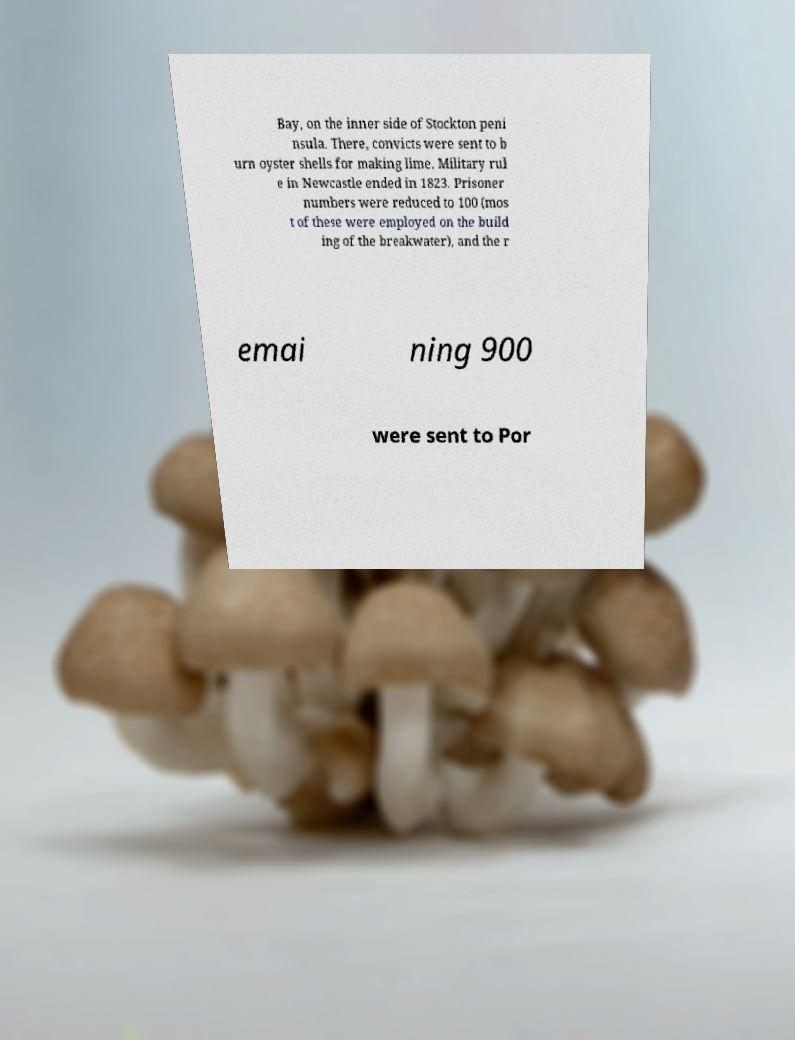For documentation purposes, I need the text within this image transcribed. Could you provide that? Bay, on the inner side of Stockton peni nsula. There, convicts were sent to b urn oyster shells for making lime. Military rul e in Newcastle ended in 1823. Prisoner numbers were reduced to 100 (mos t of these were employed on the build ing of the breakwater), and the r emai ning 900 were sent to Por 